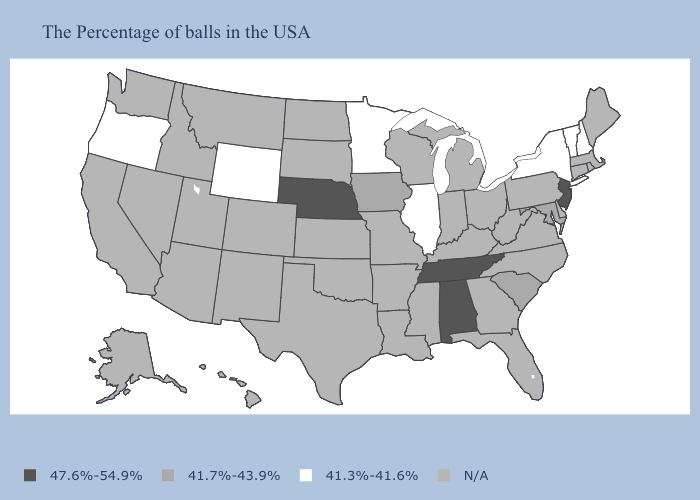Does New Hampshire have the lowest value in the USA?
Answer briefly. Yes. Is the legend a continuous bar?
Short answer required. No. What is the lowest value in the USA?
Give a very brief answer. 41.3%-41.6%. What is the value of Indiana?
Answer briefly. N/A. Among the states that border California , which have the lowest value?
Quick response, please. Oregon. What is the highest value in the West ?
Write a very short answer. 41.3%-41.6%. Among the states that border Tennessee , which have the highest value?
Keep it brief. Alabama. Name the states that have a value in the range 41.3%-41.6%?
Write a very short answer. New Hampshire, Vermont, New York, Illinois, Minnesota, Wyoming, Oregon. Does Maryland have the lowest value in the South?
Give a very brief answer. Yes. Which states have the highest value in the USA?
Be succinct. New Jersey, Alabama, Tennessee, Nebraska. Among the states that border Connecticut , which have the highest value?
Answer briefly. New York. 